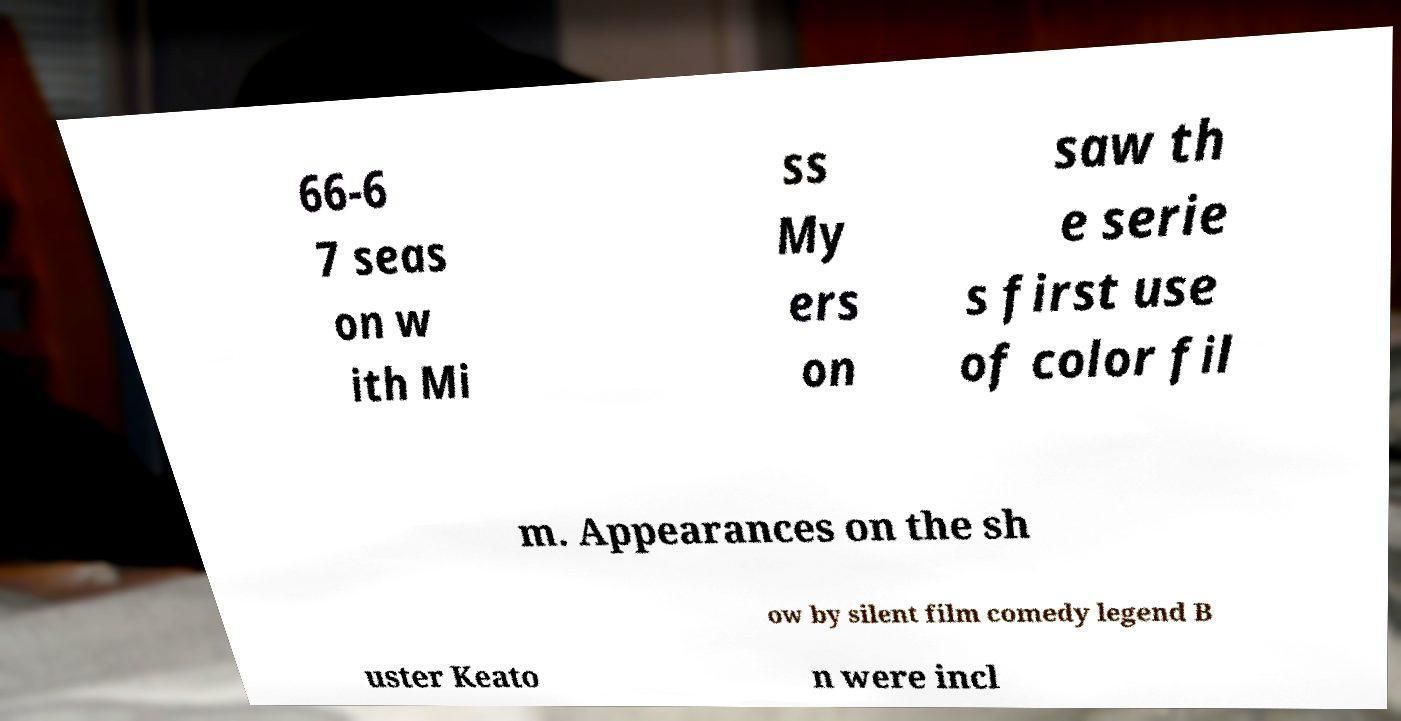I need the written content from this picture converted into text. Can you do that? 66-6 7 seas on w ith Mi ss My ers on saw th e serie s first use of color fil m. Appearances on the sh ow by silent film comedy legend B uster Keato n were incl 